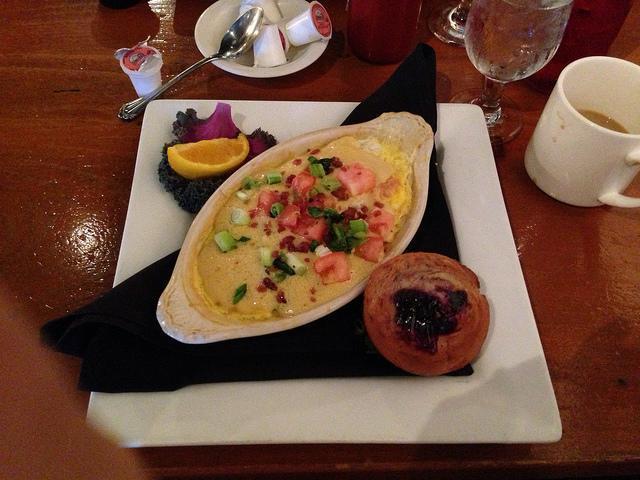What is in the little white plastic containers?
Select the accurate response from the four choices given to answer the question.
Options: Coffee creamer, ketchup, jelly, butter. Coffee creamer. 